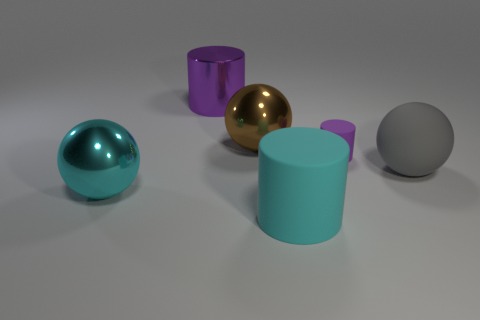There is a gray object that is made of the same material as the small purple cylinder; what shape is it?
Your answer should be very brief. Sphere. Is the shape of the purple object that is right of the purple metal thing the same as  the big purple object?
Your answer should be compact. Yes. There is a large metallic thing in front of the large brown metal ball; what is its shape?
Make the answer very short. Sphere. There is a matte object that is the same color as the shiny cylinder; what is its shape?
Keep it short and to the point. Cylinder. What number of metal cylinders are the same size as the brown shiny sphere?
Provide a succinct answer. 1. The large shiny cylinder is what color?
Keep it short and to the point. Purple. Does the big rubber cylinder have the same color as the big metallic object that is in front of the big gray object?
Give a very brief answer. Yes. What size is the ball that is made of the same material as the cyan cylinder?
Provide a succinct answer. Large. Is there a big shiny cylinder that has the same color as the small object?
Offer a terse response. Yes. What number of objects are cyan objects that are on the right side of the cyan shiny object or large cyan matte cylinders?
Provide a succinct answer. 1. 